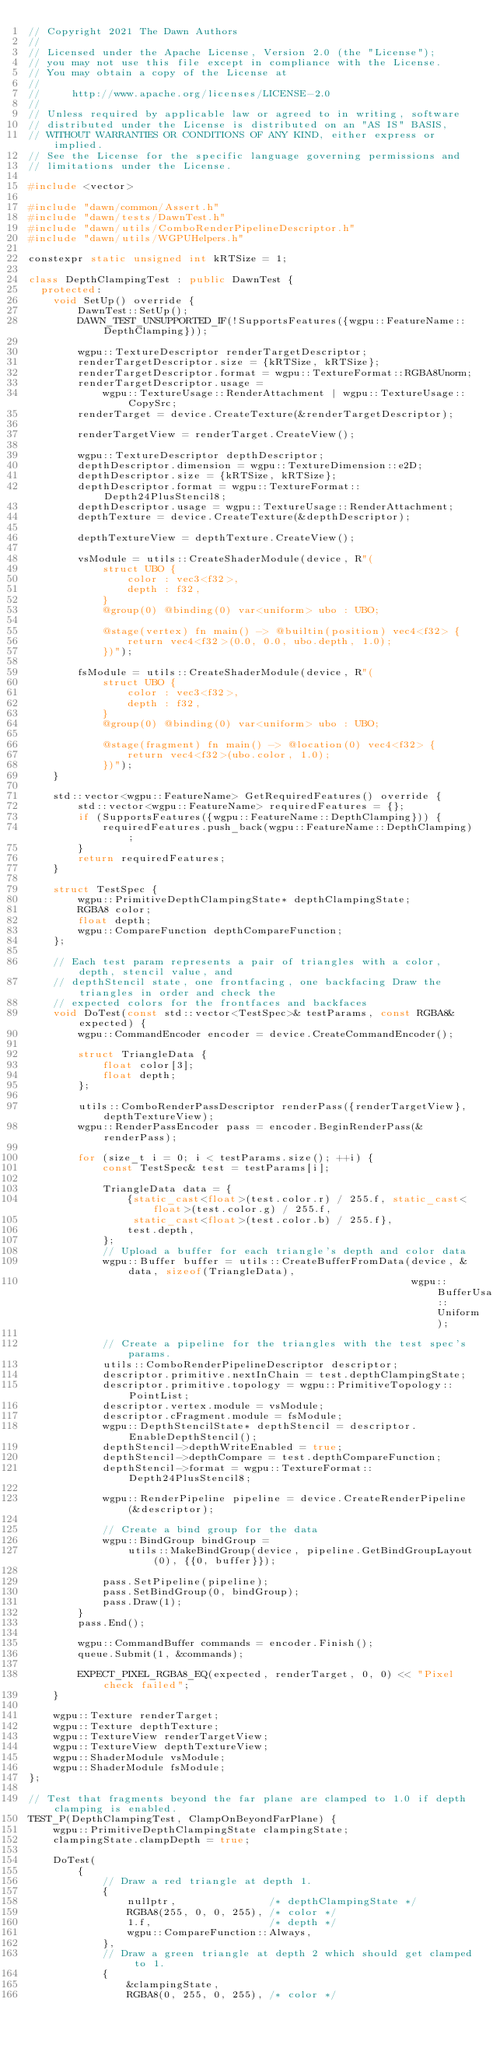Convert code to text. <code><loc_0><loc_0><loc_500><loc_500><_C++_>// Copyright 2021 The Dawn Authors
//
// Licensed under the Apache License, Version 2.0 (the "License");
// you may not use this file except in compliance with the License.
// You may obtain a copy of the License at
//
//     http://www.apache.org/licenses/LICENSE-2.0
//
// Unless required by applicable law or agreed to in writing, software
// distributed under the License is distributed on an "AS IS" BASIS,
// WITHOUT WARRANTIES OR CONDITIONS OF ANY KIND, either express or implied.
// See the License for the specific language governing permissions and
// limitations under the License.

#include <vector>

#include "dawn/common/Assert.h"
#include "dawn/tests/DawnTest.h"
#include "dawn/utils/ComboRenderPipelineDescriptor.h"
#include "dawn/utils/WGPUHelpers.h"

constexpr static unsigned int kRTSize = 1;

class DepthClampingTest : public DawnTest {
  protected:
    void SetUp() override {
        DawnTest::SetUp();
        DAWN_TEST_UNSUPPORTED_IF(!SupportsFeatures({wgpu::FeatureName::DepthClamping}));

        wgpu::TextureDescriptor renderTargetDescriptor;
        renderTargetDescriptor.size = {kRTSize, kRTSize};
        renderTargetDescriptor.format = wgpu::TextureFormat::RGBA8Unorm;
        renderTargetDescriptor.usage =
            wgpu::TextureUsage::RenderAttachment | wgpu::TextureUsage::CopySrc;
        renderTarget = device.CreateTexture(&renderTargetDescriptor);

        renderTargetView = renderTarget.CreateView();

        wgpu::TextureDescriptor depthDescriptor;
        depthDescriptor.dimension = wgpu::TextureDimension::e2D;
        depthDescriptor.size = {kRTSize, kRTSize};
        depthDescriptor.format = wgpu::TextureFormat::Depth24PlusStencil8;
        depthDescriptor.usage = wgpu::TextureUsage::RenderAttachment;
        depthTexture = device.CreateTexture(&depthDescriptor);

        depthTextureView = depthTexture.CreateView();

        vsModule = utils::CreateShaderModule(device, R"(
            struct UBO {
                color : vec3<f32>,
                depth : f32,
            }
            @group(0) @binding(0) var<uniform> ubo : UBO;

            @stage(vertex) fn main() -> @builtin(position) vec4<f32> {
                return vec4<f32>(0.0, 0.0, ubo.depth, 1.0);
            })");

        fsModule = utils::CreateShaderModule(device, R"(
            struct UBO {
                color : vec3<f32>,
                depth : f32,
            }
            @group(0) @binding(0) var<uniform> ubo : UBO;

            @stage(fragment) fn main() -> @location(0) vec4<f32> {
                return vec4<f32>(ubo.color, 1.0);
            })");
    }

    std::vector<wgpu::FeatureName> GetRequiredFeatures() override {
        std::vector<wgpu::FeatureName> requiredFeatures = {};
        if (SupportsFeatures({wgpu::FeatureName::DepthClamping})) {
            requiredFeatures.push_back(wgpu::FeatureName::DepthClamping);
        }
        return requiredFeatures;
    }

    struct TestSpec {
        wgpu::PrimitiveDepthClampingState* depthClampingState;
        RGBA8 color;
        float depth;
        wgpu::CompareFunction depthCompareFunction;
    };

    // Each test param represents a pair of triangles with a color, depth, stencil value, and
    // depthStencil state, one frontfacing, one backfacing Draw the triangles in order and check the
    // expected colors for the frontfaces and backfaces
    void DoTest(const std::vector<TestSpec>& testParams, const RGBA8& expected) {
        wgpu::CommandEncoder encoder = device.CreateCommandEncoder();

        struct TriangleData {
            float color[3];
            float depth;
        };

        utils::ComboRenderPassDescriptor renderPass({renderTargetView}, depthTextureView);
        wgpu::RenderPassEncoder pass = encoder.BeginRenderPass(&renderPass);

        for (size_t i = 0; i < testParams.size(); ++i) {
            const TestSpec& test = testParams[i];

            TriangleData data = {
                {static_cast<float>(test.color.r) / 255.f, static_cast<float>(test.color.g) / 255.f,
                 static_cast<float>(test.color.b) / 255.f},
                test.depth,
            };
            // Upload a buffer for each triangle's depth and color data
            wgpu::Buffer buffer = utils::CreateBufferFromData(device, &data, sizeof(TriangleData),
                                                              wgpu::BufferUsage::Uniform);

            // Create a pipeline for the triangles with the test spec's params.
            utils::ComboRenderPipelineDescriptor descriptor;
            descriptor.primitive.nextInChain = test.depthClampingState;
            descriptor.primitive.topology = wgpu::PrimitiveTopology::PointList;
            descriptor.vertex.module = vsModule;
            descriptor.cFragment.module = fsModule;
            wgpu::DepthStencilState* depthStencil = descriptor.EnableDepthStencil();
            depthStencil->depthWriteEnabled = true;
            depthStencil->depthCompare = test.depthCompareFunction;
            depthStencil->format = wgpu::TextureFormat::Depth24PlusStencil8;

            wgpu::RenderPipeline pipeline = device.CreateRenderPipeline(&descriptor);

            // Create a bind group for the data
            wgpu::BindGroup bindGroup =
                utils::MakeBindGroup(device, pipeline.GetBindGroupLayout(0), {{0, buffer}});

            pass.SetPipeline(pipeline);
            pass.SetBindGroup(0, bindGroup);
            pass.Draw(1);
        }
        pass.End();

        wgpu::CommandBuffer commands = encoder.Finish();
        queue.Submit(1, &commands);

        EXPECT_PIXEL_RGBA8_EQ(expected, renderTarget, 0, 0) << "Pixel check failed";
    }

    wgpu::Texture renderTarget;
    wgpu::Texture depthTexture;
    wgpu::TextureView renderTargetView;
    wgpu::TextureView depthTextureView;
    wgpu::ShaderModule vsModule;
    wgpu::ShaderModule fsModule;
};

// Test that fragments beyond the far plane are clamped to 1.0 if depth clamping is enabled.
TEST_P(DepthClampingTest, ClampOnBeyondFarPlane) {
    wgpu::PrimitiveDepthClampingState clampingState;
    clampingState.clampDepth = true;

    DoTest(
        {
            // Draw a red triangle at depth 1.
            {
                nullptr,               /* depthClampingState */
                RGBA8(255, 0, 0, 255), /* color */
                1.f,                   /* depth */
                wgpu::CompareFunction::Always,
            },
            // Draw a green triangle at depth 2 which should get clamped to 1.
            {
                &clampingState,
                RGBA8(0, 255, 0, 255), /* color */</code> 